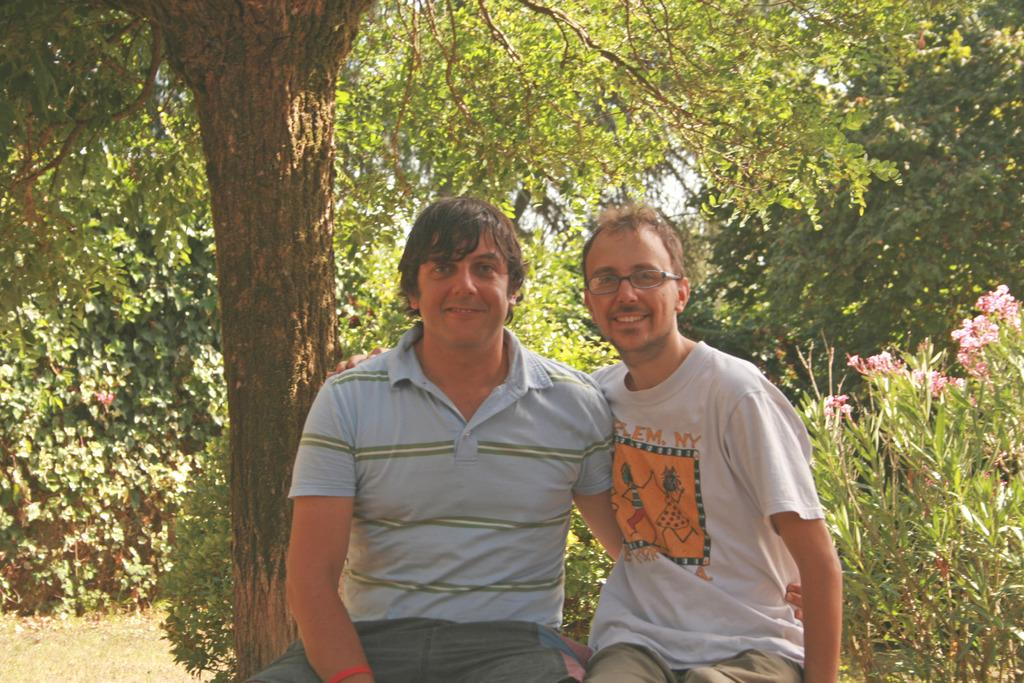How many people are in the image? There are two persons in the image. What are the two persons doing in the image? The two persons are sitting. What expressions do the two persons have in the image? The two persons are smiling. What can be seen in the background of the image? There are plants, flowers, and trees in the background of the image. What type of comfort can be seen being offered by the tongue in the image? There is no tongue present in the image, and therefore no comfort can be offered by it. 